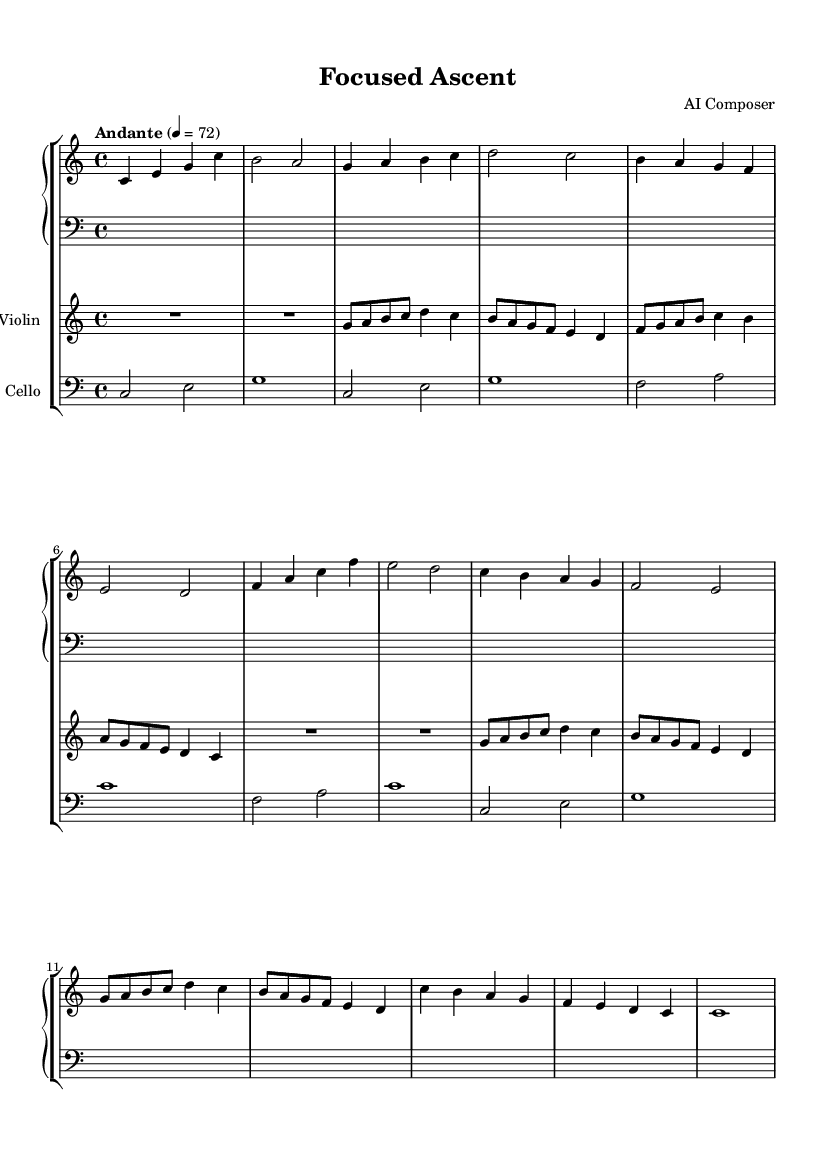What is the key signature of this music? The key signature is indicated by the absence of sharps or flats, which is characteristic of C major.
Answer: C major What is the time signature of this composition? The time signature is given as 4/4, which means there are four beats in a measure and the quarter note gets one beat.
Answer: 4/4 What is the tempo marking of this piece? The tempo marking "Andante" indicates a moderate pace, typically around 76-108 beats per minute. The numerical indication of 4 = 72 confirms the tempo to be at 72 beats per minute.
Answer: Andante How many measures are in the piano part? By counting the measures in the piano part, we note there are 16 distinct measures before the last double bar, indicating the end of the piece.
Answer: 16 What is the highest note played by the violin? In the violin part, the highest note present is g", which appears in measures where the violin plays above the staff and is indicated by the " mark.
Answer: g" How many instruments are featured in this composition? The score clearly shows three distinct staves, which represent the piano, violin, and cello, indicating a total of three instruments featured in the composition.
Answer: Three What is the function of the cello in this piece? The cello typically provides harmonic support in a composition, marked by its bass clef part which plays lower notes and complements the higher instruments, hence establishing a foundation for the piece.
Answer: Harmonic support 